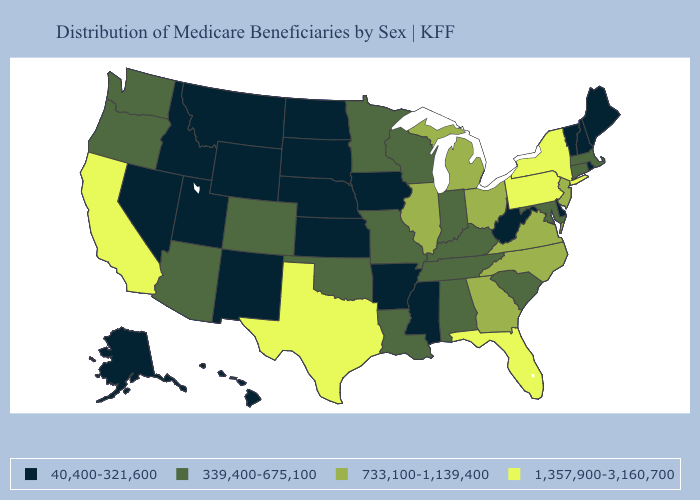What is the highest value in the USA?
Write a very short answer. 1,357,900-3,160,700. Which states have the lowest value in the USA?
Write a very short answer. Alaska, Arkansas, Delaware, Hawaii, Idaho, Iowa, Kansas, Maine, Mississippi, Montana, Nebraska, Nevada, New Hampshire, New Mexico, North Dakota, Rhode Island, South Dakota, Utah, Vermont, West Virginia, Wyoming. What is the value of Tennessee?
Keep it brief. 339,400-675,100. Does Washington have a higher value than Iowa?
Write a very short answer. Yes. Which states have the highest value in the USA?
Short answer required. California, Florida, New York, Pennsylvania, Texas. Does New Jersey have the same value as Florida?
Keep it brief. No. What is the highest value in the MidWest ?
Short answer required. 733,100-1,139,400. What is the lowest value in states that border Colorado?
Be succinct. 40,400-321,600. What is the value of Tennessee?
Short answer required. 339,400-675,100. Does Mississippi have the lowest value in the South?
Keep it brief. Yes. Name the states that have a value in the range 1,357,900-3,160,700?
Give a very brief answer. California, Florida, New York, Pennsylvania, Texas. Which states have the lowest value in the MidWest?
Be succinct. Iowa, Kansas, Nebraska, North Dakota, South Dakota. What is the value of Michigan?
Write a very short answer. 733,100-1,139,400. Does Arkansas have a lower value than Michigan?
Concise answer only. Yes. Which states have the lowest value in the USA?
Quick response, please. Alaska, Arkansas, Delaware, Hawaii, Idaho, Iowa, Kansas, Maine, Mississippi, Montana, Nebraska, Nevada, New Hampshire, New Mexico, North Dakota, Rhode Island, South Dakota, Utah, Vermont, West Virginia, Wyoming. 